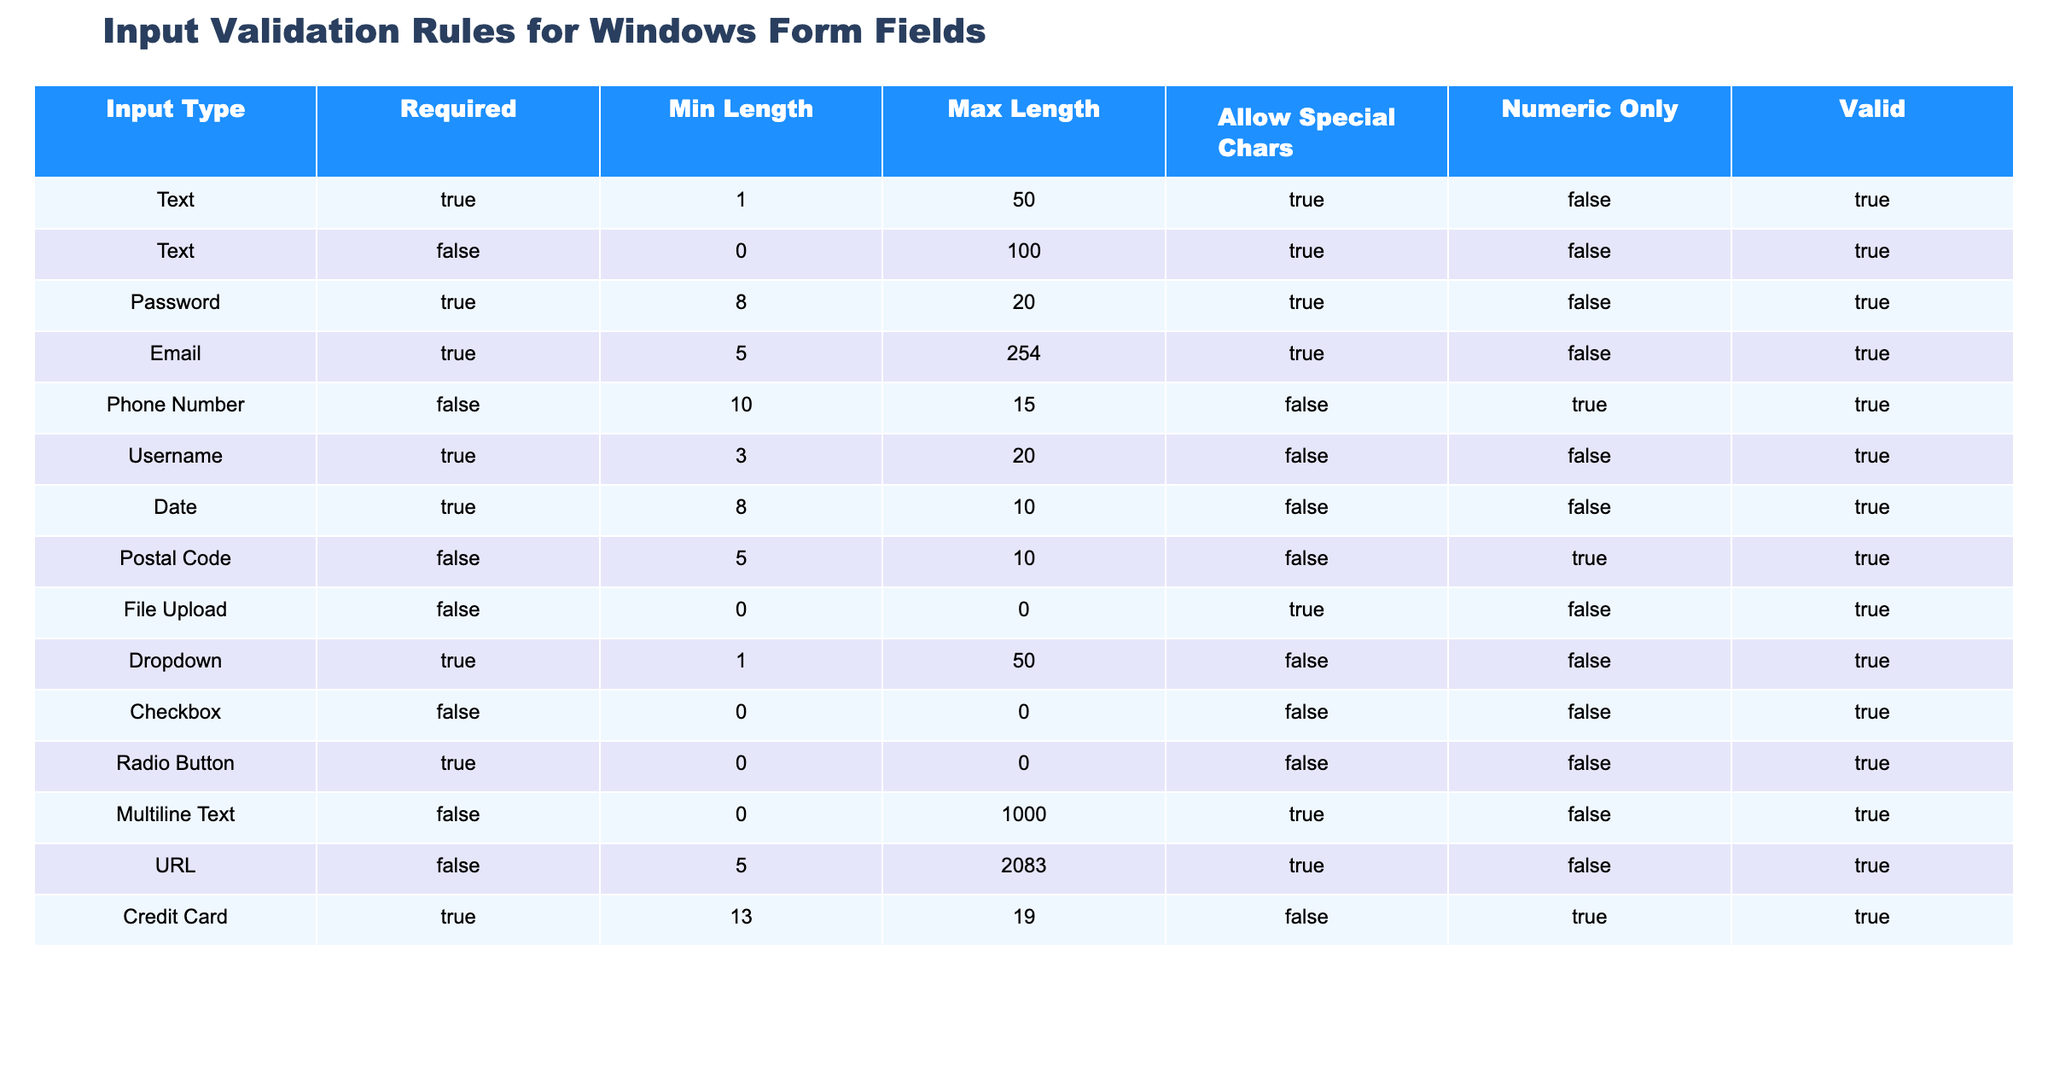What is the maximum length allowed for an Email input? The maximum length for an Email input is listed in the "Max Length" column corresponding to the "Email" row, which states 254 characters.
Answer: 254 Is a Username input required? The "Required" column for the Username field indicates TRUE, meaning this field must be completed.
Answer: Yes What input types allow special characters? By examining the "Allow Special Chars" column, we see that the input types that allow special characters are Text, Password, Email, and File Upload.
Answer: Text, Password, Email, File Upload How many input types have a minimum length of less than 5? The input types with a minimum length of less than 5 are the ones counted from the "Min Length" column. From our data, they are Text (0), File Upload (0), and Checkbox (0), giving us a total of 3 input types.
Answer: 3 Is a Credit Card input type required and does it allow special characters? The "Required" column for Credit Card indicates TRUE, confirming it must be filled out, while the "Allow Special Chars" column indicates FALSE, showing special characters are not allowed.
Answer: Yes, No What is the total number of input types classified as Numeric Only? The "Numeric Only" column reveals the input types that allow only numbers are Phone Number and Credit Card. There are 2 such types.
Answer: 2 Which input type has the largest max length? By comparing the "Max Length" values, Email has the largest at 254 characters.
Answer: Email How many fields have a "Valid" status of TRUE? From the "Valid" column, we can evaluate the rows marked TRUE. All input types except "Postal Code" are valid, totaling 10 fields marked as valid.
Answer: 10 Which field requires the most characters in the minimum length? The "Min Length" column shows Password is the highest at 8 characters required minimum.
Answer: Password 